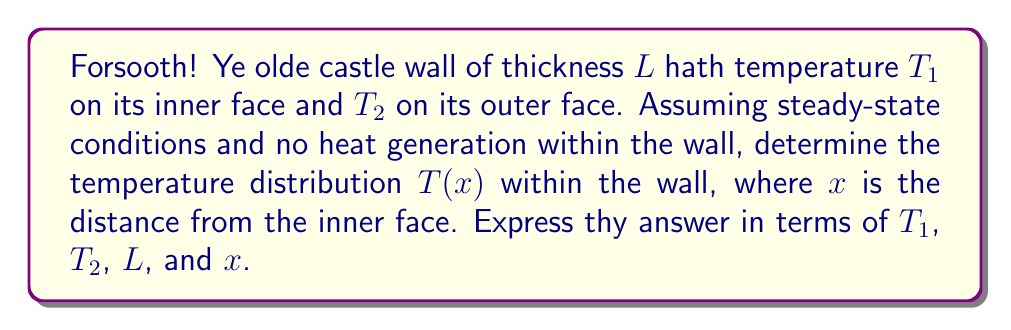Can you solve this math problem? 1. We shall use the one-dimensional steady-state heat equation:
   $$\frac{d^2T}{dx^2} = 0$$

2. Integrate this equation once:
   $$\frac{dT}{dx} = C_1$$

3. Integrate again:
   $$T(x) = C_1x + C_2$$

4. Apply boundary conditions:
   At $x = 0$, $T(0) = T_1$, thus $C_2 = T_1$
   At $x = L$, $T(L) = T_2$, thus $C_1L + T_1 = T_2$

5. Solve for $C_1$:
   $$C_1 = \frac{T_2 - T_1}{L}$$

6. Substitute $C_1$ and $C_2$ into the general solution:
   $$T(x) = \frac{T_2 - T_1}{L}x + T_1$$

7. Rearrange to express in terms of $T_1$, $T_2$, $L$, and $x$:
   $$T(x) = T_1 + (T_2 - T_1)\frac{x}{L}$$
Answer: $T(x) = T_1 + (T_2 - T_1)\frac{x}{L}$ 